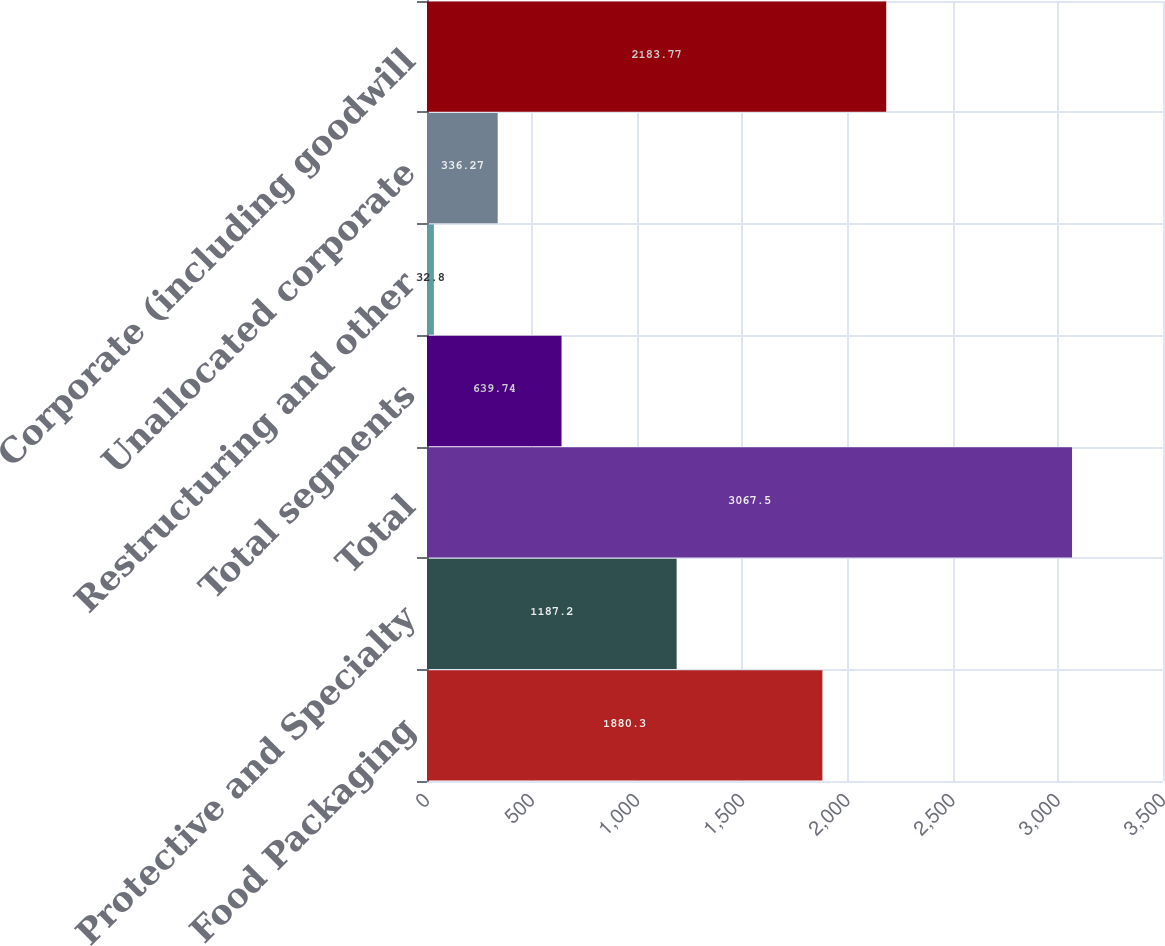Convert chart. <chart><loc_0><loc_0><loc_500><loc_500><bar_chart><fcel>Food Packaging<fcel>Protective and Specialty<fcel>Total<fcel>Total segments<fcel>Restructuring and other<fcel>Unallocated corporate<fcel>Corporate (including goodwill<nl><fcel>1880.3<fcel>1187.2<fcel>3067.5<fcel>639.74<fcel>32.8<fcel>336.27<fcel>2183.77<nl></chart> 